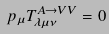<formula> <loc_0><loc_0><loc_500><loc_500>p _ { \mu } T ^ { A \rightarrow V V } _ { \lambda \mu \nu } = 0</formula> 